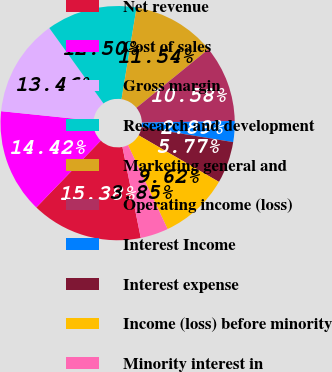Convert chart to OTSL. <chart><loc_0><loc_0><loc_500><loc_500><pie_chart><fcel>Net revenue<fcel>Cost of sales<fcel>Gross margin<fcel>Research and development<fcel>Marketing general and<fcel>Operating income (loss)<fcel>Interest Income<fcel>Interest expense<fcel>Income (loss) before minority<fcel>Minority interest in<nl><fcel>15.38%<fcel>14.42%<fcel>13.46%<fcel>12.5%<fcel>11.54%<fcel>10.58%<fcel>2.89%<fcel>5.77%<fcel>9.62%<fcel>3.85%<nl></chart> 